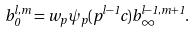Convert formula to latex. <formula><loc_0><loc_0><loc_500><loc_500>b _ { 0 } ^ { l , m } = w _ { p } \psi _ { p } ( p ^ { l - 1 } c ) b _ { \infty } ^ { l - 1 , m + 1 } .</formula> 